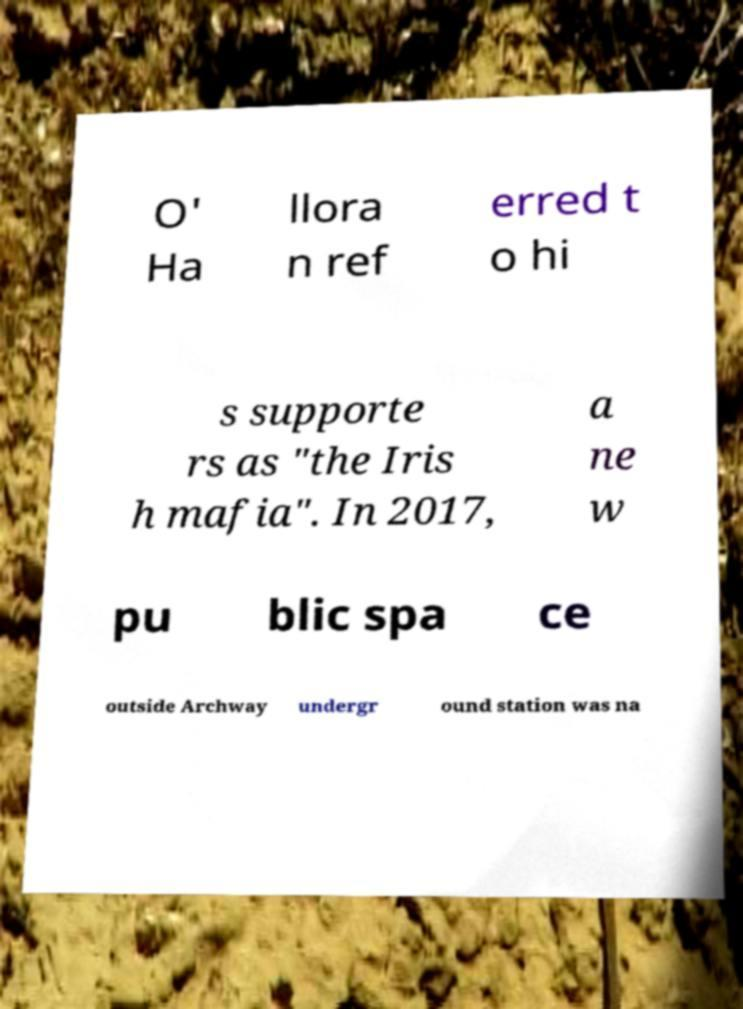Could you assist in decoding the text presented in this image and type it out clearly? O' Ha llora n ref erred t o hi s supporte rs as "the Iris h mafia". In 2017, a ne w pu blic spa ce outside Archway undergr ound station was na 